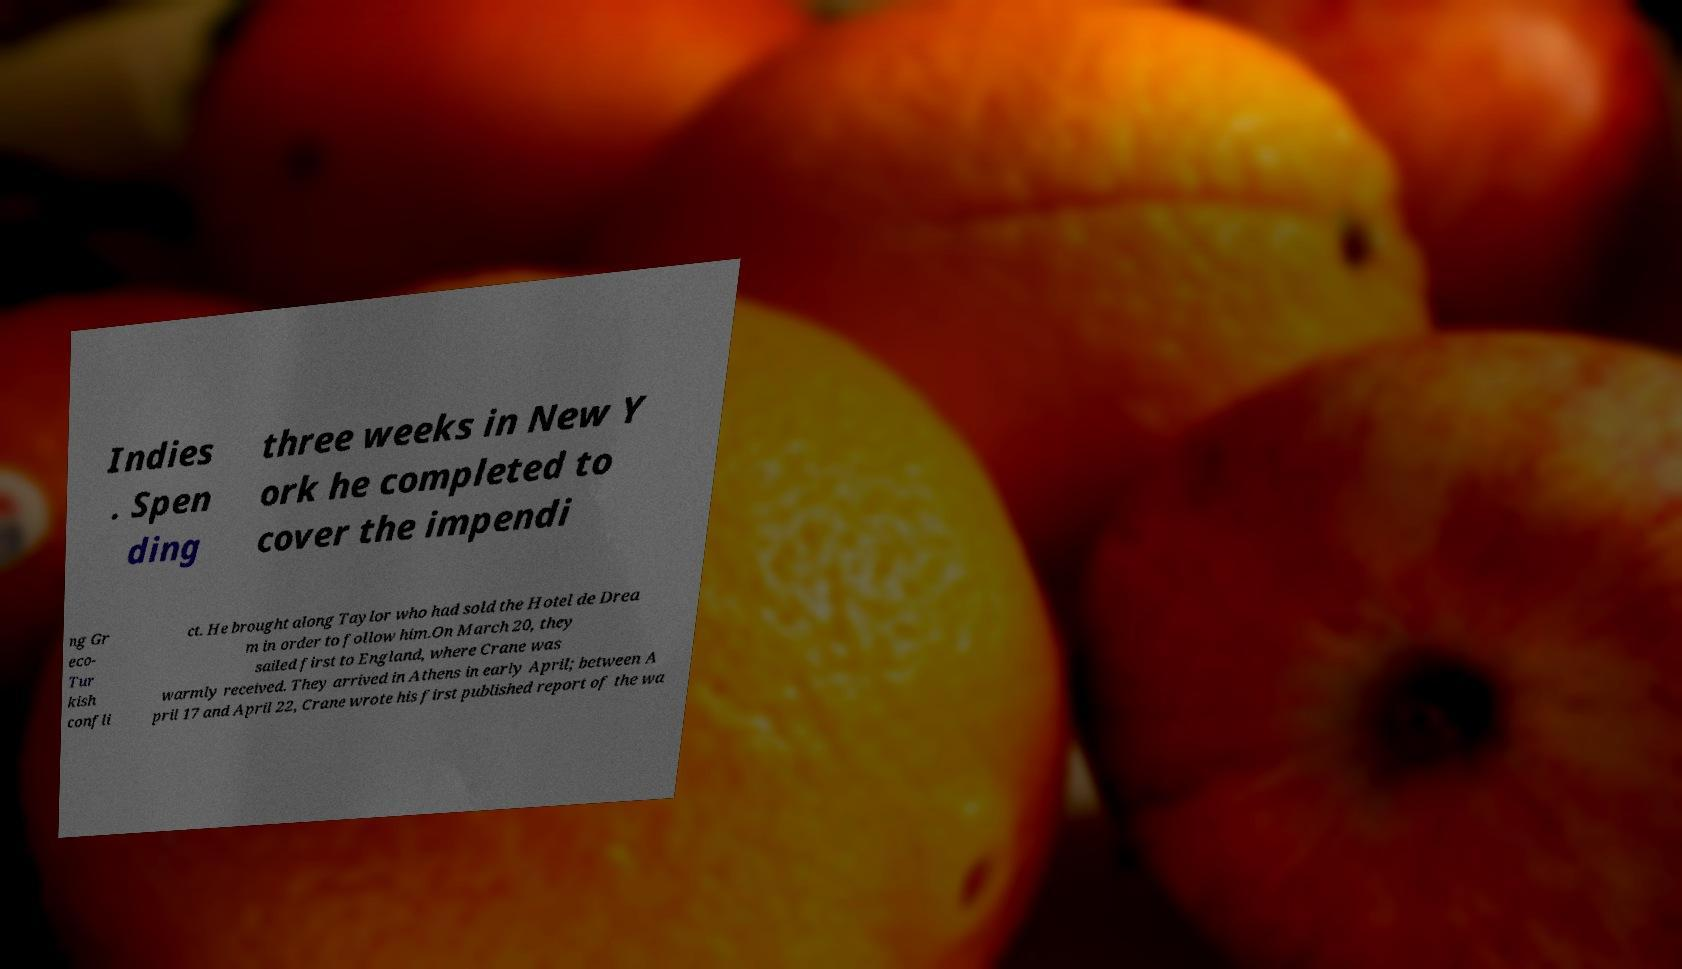Can you read and provide the text displayed in the image?This photo seems to have some interesting text. Can you extract and type it out for me? Indies . Spen ding three weeks in New Y ork he completed to cover the impendi ng Gr eco- Tur kish confli ct. He brought along Taylor who had sold the Hotel de Drea m in order to follow him.On March 20, they sailed first to England, where Crane was warmly received. They arrived in Athens in early April; between A pril 17 and April 22, Crane wrote his first published report of the wa 